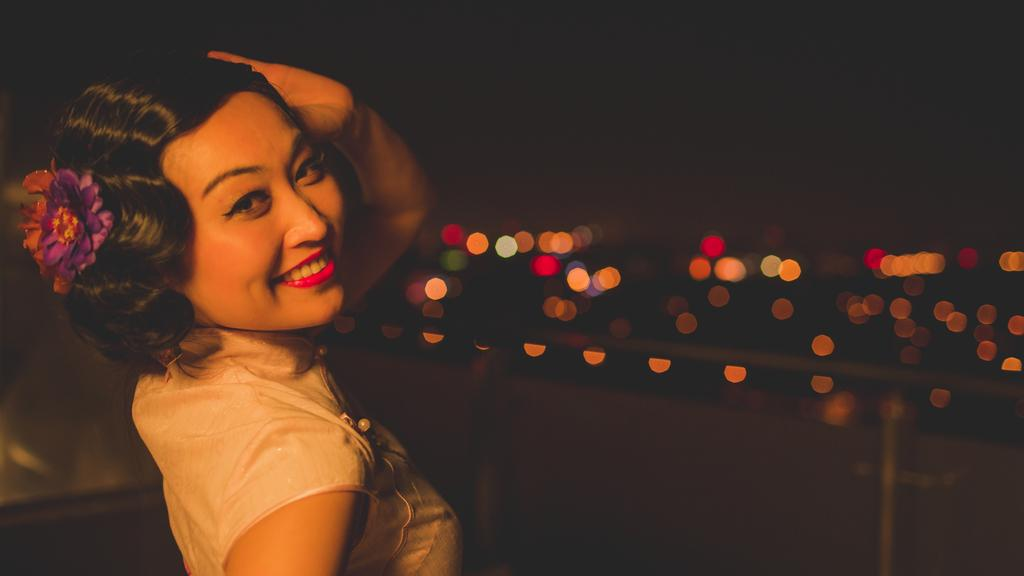Who is the main subject in the foreground of the image? There is a woman in the foreground of the image. What is the woman doing in the image? The woman is smiling. What can be seen in the background of the image? There is a wall and lights visible in the background of the image. What type of horn is the minister playing in the image? There is no minister or horn present in the image. What advice does the woman's uncle give her in the image? There is no uncle present in the image, and therefore no advice can be given. 